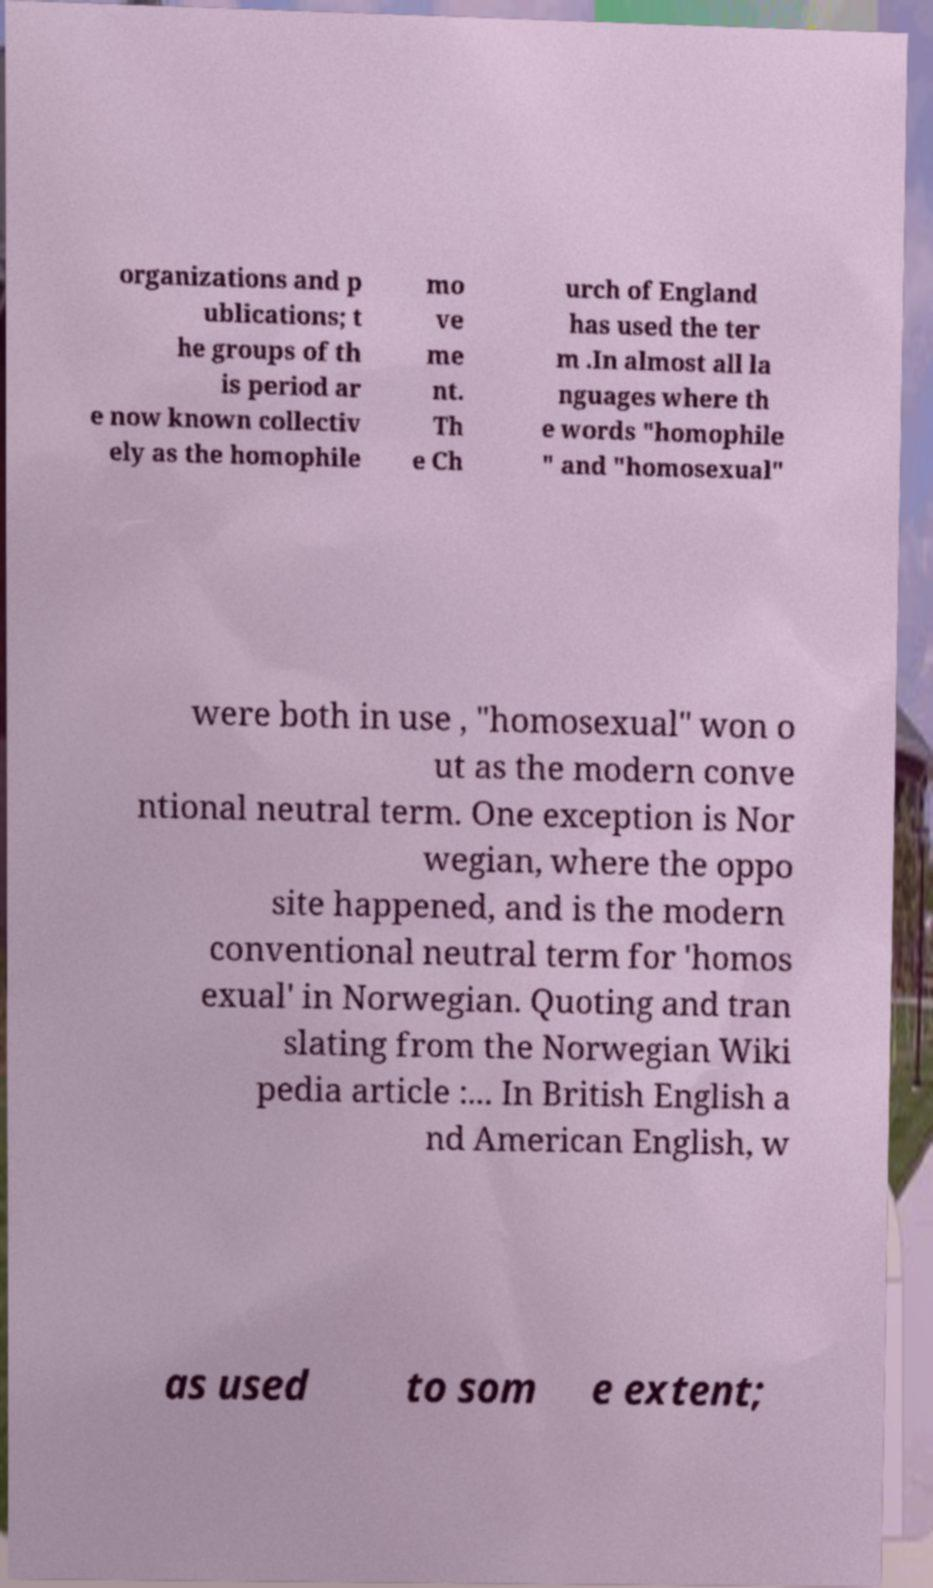Could you assist in decoding the text presented in this image and type it out clearly? organizations and p ublications; t he groups of th is period ar e now known collectiv ely as the homophile mo ve me nt. Th e Ch urch of England has used the ter m .In almost all la nguages where th e words "homophile " and "homosexual" were both in use , "homosexual" won o ut as the modern conve ntional neutral term. One exception is Nor wegian, where the oppo site happened, and is the modern conventional neutral term for 'homos exual' in Norwegian. Quoting and tran slating from the Norwegian Wiki pedia article :... In British English a nd American English, w as used to som e extent; 